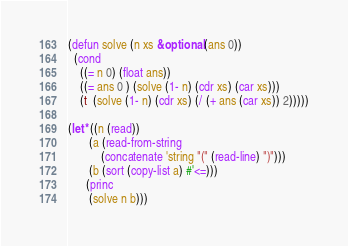Convert code to text. <code><loc_0><loc_0><loc_500><loc_500><_Lisp_>(defun solve (n xs &optional (ans 0))
  (cond
    ((= n 0) (float ans))
    ((= ans 0 ) (solve (1- n) (cdr xs) (car xs)))      
    (t  (solve (1- n) (cdr xs) (/ (+ ans (car xs)) 2)))))

(let* ((n (read))
       (a (read-from-string
           (concatenate 'string "(" (read-line) ")")))
       (b (sort (copy-list a) #'<=)))
      (princ
       (solve n b)))</code> 